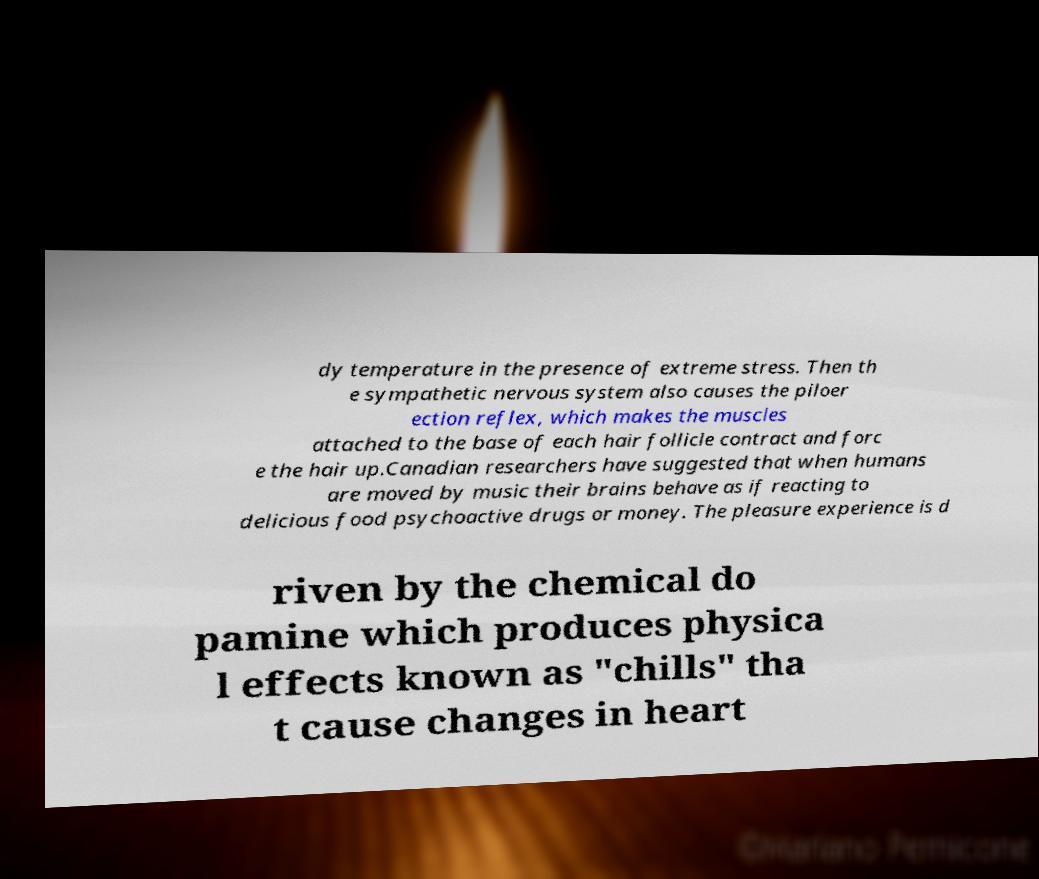For documentation purposes, I need the text within this image transcribed. Could you provide that? dy temperature in the presence of extreme stress. Then th e sympathetic nervous system also causes the piloer ection reflex, which makes the muscles attached to the base of each hair follicle contract and forc e the hair up.Canadian researchers have suggested that when humans are moved by music their brains behave as if reacting to delicious food psychoactive drugs or money. The pleasure experience is d riven by the chemical do pamine which produces physica l effects known as "chills" tha t cause changes in heart 